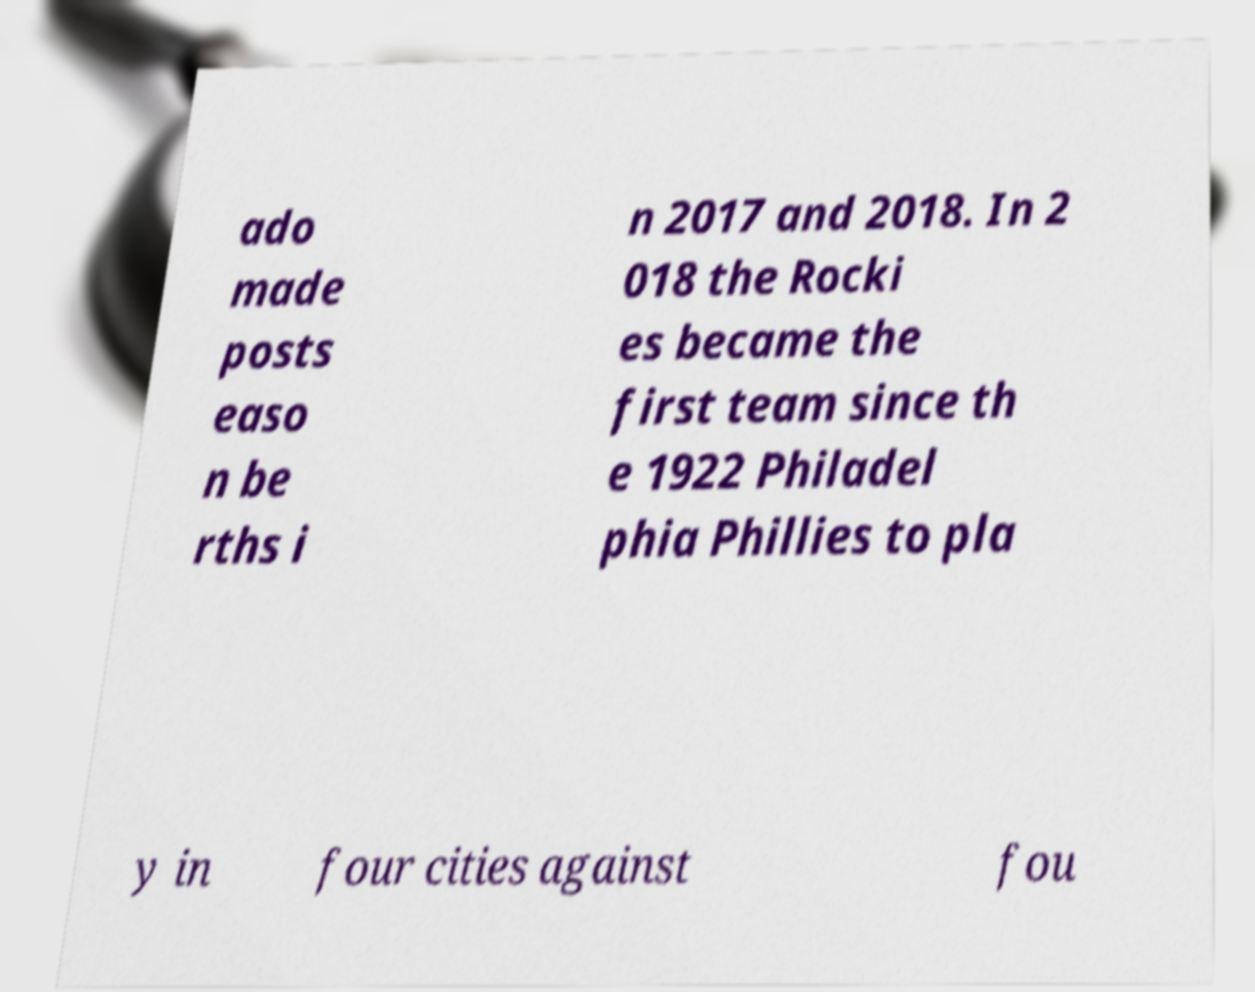Could you assist in decoding the text presented in this image and type it out clearly? ado made posts easo n be rths i n 2017 and 2018. In 2 018 the Rocki es became the first team since th e 1922 Philadel phia Phillies to pla y in four cities against fou 